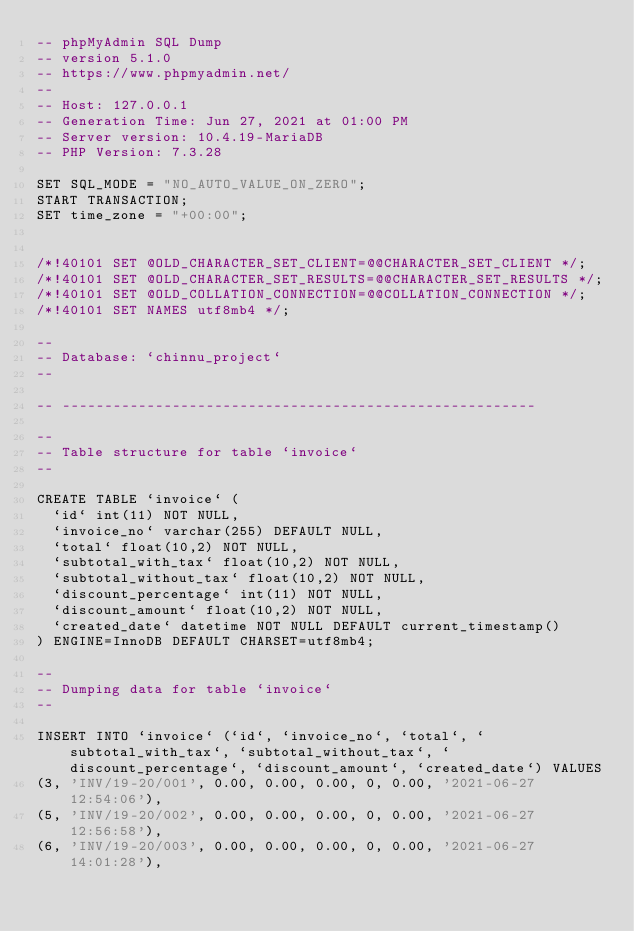Convert code to text. <code><loc_0><loc_0><loc_500><loc_500><_SQL_>-- phpMyAdmin SQL Dump
-- version 5.1.0
-- https://www.phpmyadmin.net/
--
-- Host: 127.0.0.1
-- Generation Time: Jun 27, 2021 at 01:00 PM
-- Server version: 10.4.19-MariaDB
-- PHP Version: 7.3.28

SET SQL_MODE = "NO_AUTO_VALUE_ON_ZERO";
START TRANSACTION;
SET time_zone = "+00:00";


/*!40101 SET @OLD_CHARACTER_SET_CLIENT=@@CHARACTER_SET_CLIENT */;
/*!40101 SET @OLD_CHARACTER_SET_RESULTS=@@CHARACTER_SET_RESULTS */;
/*!40101 SET @OLD_COLLATION_CONNECTION=@@COLLATION_CONNECTION */;
/*!40101 SET NAMES utf8mb4 */;

--
-- Database: `chinnu_project`
--

-- --------------------------------------------------------

--
-- Table structure for table `invoice`
--

CREATE TABLE `invoice` (
  `id` int(11) NOT NULL,
  `invoice_no` varchar(255) DEFAULT NULL,
  `total` float(10,2) NOT NULL,
  `subtotal_with_tax` float(10,2) NOT NULL,
  `subtotal_without_tax` float(10,2) NOT NULL,
  `discount_percentage` int(11) NOT NULL,
  `discount_amount` float(10,2) NOT NULL,
  `created_date` datetime NOT NULL DEFAULT current_timestamp()
) ENGINE=InnoDB DEFAULT CHARSET=utf8mb4;

--
-- Dumping data for table `invoice`
--

INSERT INTO `invoice` (`id`, `invoice_no`, `total`, `subtotal_with_tax`, `subtotal_without_tax`, `discount_percentage`, `discount_amount`, `created_date`) VALUES
(3, 'INV/19-20/001', 0.00, 0.00, 0.00, 0, 0.00, '2021-06-27 12:54:06'),
(5, 'INV/19-20/002', 0.00, 0.00, 0.00, 0, 0.00, '2021-06-27 12:56:58'),
(6, 'INV/19-20/003', 0.00, 0.00, 0.00, 0, 0.00, '2021-06-27 14:01:28'),</code> 